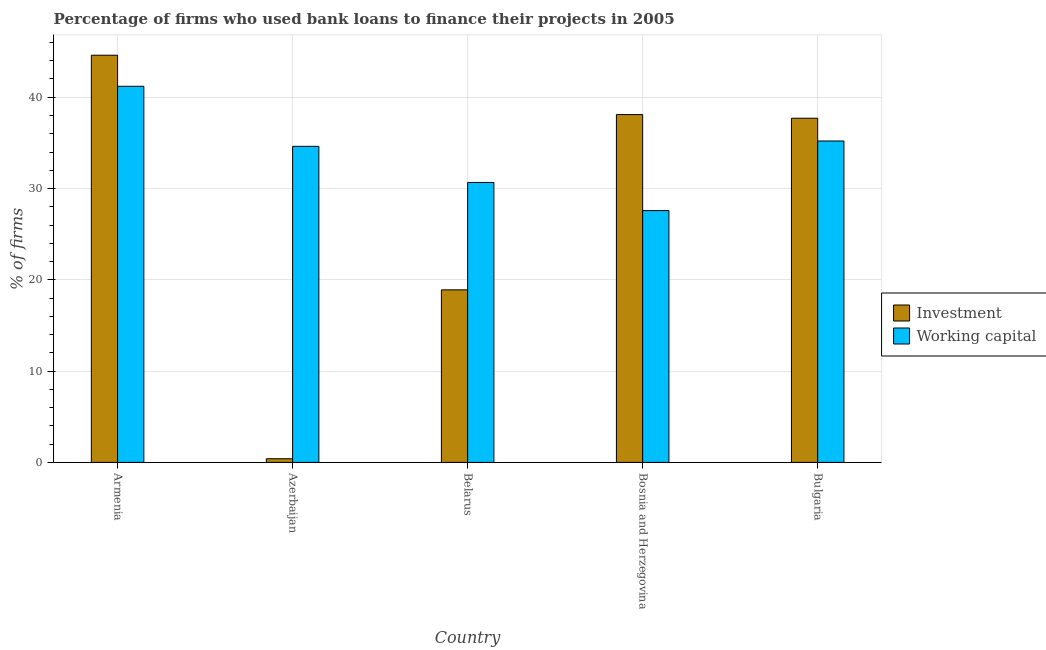How many different coloured bars are there?
Offer a terse response. 2. How many groups of bars are there?
Give a very brief answer. 5. Are the number of bars per tick equal to the number of legend labels?
Give a very brief answer. Yes. Are the number of bars on each tick of the X-axis equal?
Your answer should be very brief. Yes. What is the label of the 2nd group of bars from the left?
Ensure brevity in your answer.  Azerbaijan. In how many cases, is the number of bars for a given country not equal to the number of legend labels?
Give a very brief answer. 0. What is the percentage of firms using banks to finance working capital in Belarus?
Offer a very short reply. 30.67. Across all countries, what is the maximum percentage of firms using banks to finance working capital?
Your answer should be very brief. 41.2. Across all countries, what is the minimum percentage of firms using banks to finance working capital?
Your response must be concise. 27.58. In which country was the percentage of firms using banks to finance working capital maximum?
Make the answer very short. Armenia. In which country was the percentage of firms using banks to finance investment minimum?
Your answer should be compact. Azerbaijan. What is the total percentage of firms using banks to finance working capital in the graph?
Your response must be concise. 169.27. What is the difference between the percentage of firms using banks to finance investment in Azerbaijan and that in Belarus?
Provide a short and direct response. -18.5. What is the difference between the percentage of firms using banks to finance working capital in Azerbaijan and the percentage of firms using banks to finance investment in Armenia?
Give a very brief answer. -9.98. What is the average percentage of firms using banks to finance working capital per country?
Offer a terse response. 33.85. What is the difference between the percentage of firms using banks to finance investment and percentage of firms using banks to finance working capital in Bosnia and Herzegovina?
Keep it short and to the point. 10.52. What is the ratio of the percentage of firms using banks to finance investment in Armenia to that in Bosnia and Herzegovina?
Your answer should be compact. 1.17. Is the percentage of firms using banks to finance investment in Azerbaijan less than that in Bosnia and Herzegovina?
Make the answer very short. Yes. What is the difference between the highest and the second highest percentage of firms using banks to finance working capital?
Your answer should be very brief. 5.99. What is the difference between the highest and the lowest percentage of firms using banks to finance investment?
Keep it short and to the point. 44.2. Is the sum of the percentage of firms using banks to finance investment in Azerbaijan and Bulgaria greater than the maximum percentage of firms using banks to finance working capital across all countries?
Your answer should be compact. No. What does the 1st bar from the left in Azerbaijan represents?
Offer a terse response. Investment. What does the 1st bar from the right in Azerbaijan represents?
Your answer should be very brief. Working capital. How many bars are there?
Your answer should be compact. 10. What is the difference between two consecutive major ticks on the Y-axis?
Give a very brief answer. 10. Are the values on the major ticks of Y-axis written in scientific E-notation?
Provide a succinct answer. No. Where does the legend appear in the graph?
Provide a succinct answer. Center right. How many legend labels are there?
Make the answer very short. 2. What is the title of the graph?
Offer a very short reply. Percentage of firms who used bank loans to finance their projects in 2005. Does "2012 US$" appear as one of the legend labels in the graph?
Your response must be concise. No. What is the label or title of the Y-axis?
Provide a short and direct response. % of firms. What is the % of firms in Investment in Armenia?
Provide a succinct answer. 44.6. What is the % of firms in Working capital in Armenia?
Offer a terse response. 41.2. What is the % of firms of Working capital in Azerbaijan?
Make the answer very short. 34.62. What is the % of firms in Working capital in Belarus?
Your answer should be compact. 30.67. What is the % of firms in Investment in Bosnia and Herzegovina?
Offer a terse response. 38.1. What is the % of firms of Working capital in Bosnia and Herzegovina?
Your response must be concise. 27.58. What is the % of firms of Investment in Bulgaria?
Give a very brief answer. 37.7. What is the % of firms of Working capital in Bulgaria?
Provide a short and direct response. 35.21. Across all countries, what is the maximum % of firms of Investment?
Offer a terse response. 44.6. Across all countries, what is the maximum % of firms of Working capital?
Your answer should be compact. 41.2. Across all countries, what is the minimum % of firms of Working capital?
Your answer should be compact. 27.58. What is the total % of firms of Investment in the graph?
Your response must be concise. 139.7. What is the total % of firms in Working capital in the graph?
Provide a succinct answer. 169.27. What is the difference between the % of firms in Investment in Armenia and that in Azerbaijan?
Ensure brevity in your answer.  44.2. What is the difference between the % of firms of Working capital in Armenia and that in Azerbaijan?
Provide a succinct answer. 6.58. What is the difference between the % of firms of Investment in Armenia and that in Belarus?
Your response must be concise. 25.7. What is the difference between the % of firms in Working capital in Armenia and that in Belarus?
Your answer should be very brief. 10.53. What is the difference between the % of firms of Investment in Armenia and that in Bosnia and Herzegovina?
Give a very brief answer. 6.5. What is the difference between the % of firms in Working capital in Armenia and that in Bosnia and Herzegovina?
Give a very brief answer. 13.62. What is the difference between the % of firms of Working capital in Armenia and that in Bulgaria?
Offer a very short reply. 5.99. What is the difference between the % of firms of Investment in Azerbaijan and that in Belarus?
Provide a succinct answer. -18.5. What is the difference between the % of firms of Working capital in Azerbaijan and that in Belarus?
Your response must be concise. 3.95. What is the difference between the % of firms in Investment in Azerbaijan and that in Bosnia and Herzegovina?
Your answer should be very brief. -37.7. What is the difference between the % of firms of Working capital in Azerbaijan and that in Bosnia and Herzegovina?
Ensure brevity in your answer.  7.04. What is the difference between the % of firms in Investment in Azerbaijan and that in Bulgaria?
Make the answer very short. -37.3. What is the difference between the % of firms in Working capital in Azerbaijan and that in Bulgaria?
Make the answer very short. -0.59. What is the difference between the % of firms in Investment in Belarus and that in Bosnia and Herzegovina?
Your answer should be compact. -19.2. What is the difference between the % of firms in Working capital in Belarus and that in Bosnia and Herzegovina?
Offer a terse response. 3.08. What is the difference between the % of firms of Investment in Belarus and that in Bulgaria?
Make the answer very short. -18.8. What is the difference between the % of firms in Working capital in Belarus and that in Bulgaria?
Your answer should be very brief. -4.54. What is the difference between the % of firms in Investment in Bosnia and Herzegovina and that in Bulgaria?
Provide a short and direct response. 0.4. What is the difference between the % of firms in Working capital in Bosnia and Herzegovina and that in Bulgaria?
Offer a terse response. -7.62. What is the difference between the % of firms in Investment in Armenia and the % of firms in Working capital in Azerbaijan?
Offer a terse response. 9.98. What is the difference between the % of firms in Investment in Armenia and the % of firms in Working capital in Belarus?
Offer a very short reply. 13.93. What is the difference between the % of firms in Investment in Armenia and the % of firms in Working capital in Bosnia and Herzegovina?
Provide a short and direct response. 17.02. What is the difference between the % of firms of Investment in Armenia and the % of firms of Working capital in Bulgaria?
Your response must be concise. 9.39. What is the difference between the % of firms of Investment in Azerbaijan and the % of firms of Working capital in Belarus?
Provide a succinct answer. -30.27. What is the difference between the % of firms in Investment in Azerbaijan and the % of firms in Working capital in Bosnia and Herzegovina?
Your answer should be compact. -27.18. What is the difference between the % of firms in Investment in Azerbaijan and the % of firms in Working capital in Bulgaria?
Provide a short and direct response. -34.81. What is the difference between the % of firms of Investment in Belarus and the % of firms of Working capital in Bosnia and Herzegovina?
Make the answer very short. -8.68. What is the difference between the % of firms in Investment in Belarus and the % of firms in Working capital in Bulgaria?
Your response must be concise. -16.31. What is the difference between the % of firms in Investment in Bosnia and Herzegovina and the % of firms in Working capital in Bulgaria?
Offer a terse response. 2.89. What is the average % of firms of Investment per country?
Provide a succinct answer. 27.94. What is the average % of firms of Working capital per country?
Your response must be concise. 33.85. What is the difference between the % of firms in Investment and % of firms in Working capital in Azerbaijan?
Provide a short and direct response. -34.22. What is the difference between the % of firms in Investment and % of firms in Working capital in Belarus?
Your answer should be very brief. -11.77. What is the difference between the % of firms in Investment and % of firms in Working capital in Bosnia and Herzegovina?
Provide a short and direct response. 10.52. What is the difference between the % of firms of Investment and % of firms of Working capital in Bulgaria?
Provide a succinct answer. 2.49. What is the ratio of the % of firms of Investment in Armenia to that in Azerbaijan?
Make the answer very short. 111.5. What is the ratio of the % of firms of Working capital in Armenia to that in Azerbaijan?
Your response must be concise. 1.19. What is the ratio of the % of firms in Investment in Armenia to that in Belarus?
Your answer should be very brief. 2.36. What is the ratio of the % of firms in Working capital in Armenia to that in Belarus?
Keep it short and to the point. 1.34. What is the ratio of the % of firms of Investment in Armenia to that in Bosnia and Herzegovina?
Offer a terse response. 1.17. What is the ratio of the % of firms of Working capital in Armenia to that in Bosnia and Herzegovina?
Ensure brevity in your answer.  1.49. What is the ratio of the % of firms of Investment in Armenia to that in Bulgaria?
Keep it short and to the point. 1.18. What is the ratio of the % of firms of Working capital in Armenia to that in Bulgaria?
Give a very brief answer. 1.17. What is the ratio of the % of firms in Investment in Azerbaijan to that in Belarus?
Your answer should be compact. 0.02. What is the ratio of the % of firms of Working capital in Azerbaijan to that in Belarus?
Your answer should be compact. 1.13. What is the ratio of the % of firms of Investment in Azerbaijan to that in Bosnia and Herzegovina?
Your answer should be compact. 0.01. What is the ratio of the % of firms in Working capital in Azerbaijan to that in Bosnia and Herzegovina?
Ensure brevity in your answer.  1.26. What is the ratio of the % of firms in Investment in Azerbaijan to that in Bulgaria?
Ensure brevity in your answer.  0.01. What is the ratio of the % of firms in Working capital in Azerbaijan to that in Bulgaria?
Provide a short and direct response. 0.98. What is the ratio of the % of firms in Investment in Belarus to that in Bosnia and Herzegovina?
Provide a succinct answer. 0.5. What is the ratio of the % of firms of Working capital in Belarus to that in Bosnia and Herzegovina?
Ensure brevity in your answer.  1.11. What is the ratio of the % of firms of Investment in Belarus to that in Bulgaria?
Offer a terse response. 0.5. What is the ratio of the % of firms in Working capital in Belarus to that in Bulgaria?
Your answer should be compact. 0.87. What is the ratio of the % of firms in Investment in Bosnia and Herzegovina to that in Bulgaria?
Give a very brief answer. 1.01. What is the ratio of the % of firms in Working capital in Bosnia and Herzegovina to that in Bulgaria?
Give a very brief answer. 0.78. What is the difference between the highest and the second highest % of firms in Investment?
Make the answer very short. 6.5. What is the difference between the highest and the second highest % of firms of Working capital?
Your response must be concise. 5.99. What is the difference between the highest and the lowest % of firms in Investment?
Provide a short and direct response. 44.2. What is the difference between the highest and the lowest % of firms in Working capital?
Your answer should be very brief. 13.62. 